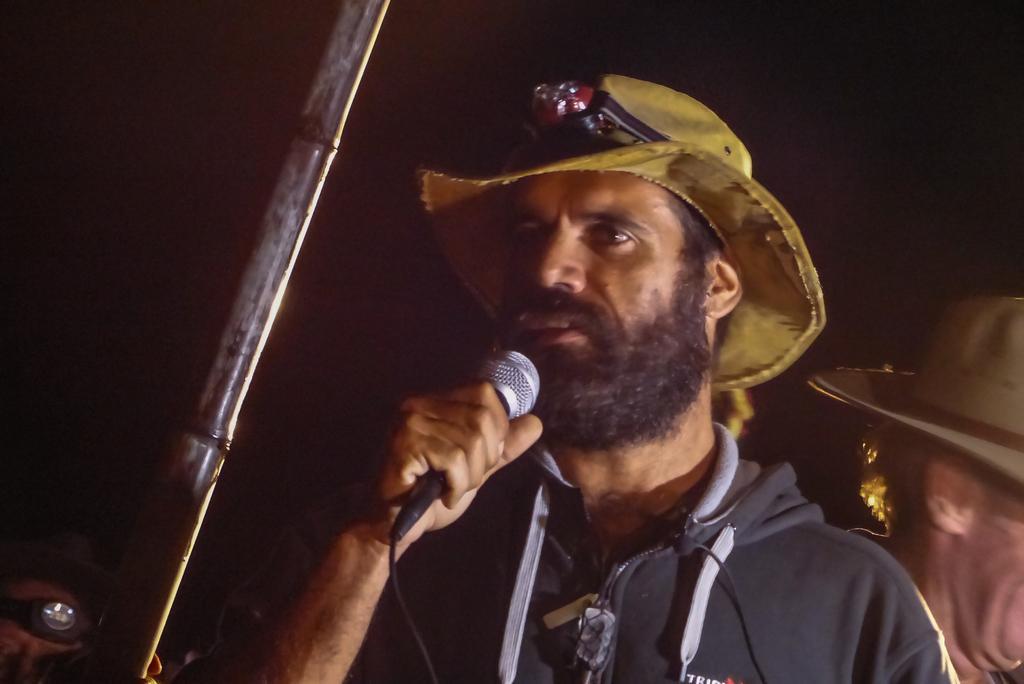In one or two sentences, can you explain what this image depicts? Background is dark. Here we can see one man wearing yellow colour hat, holding a mike in his hand and talking. Behind to him we can see two other men wearing hats. 